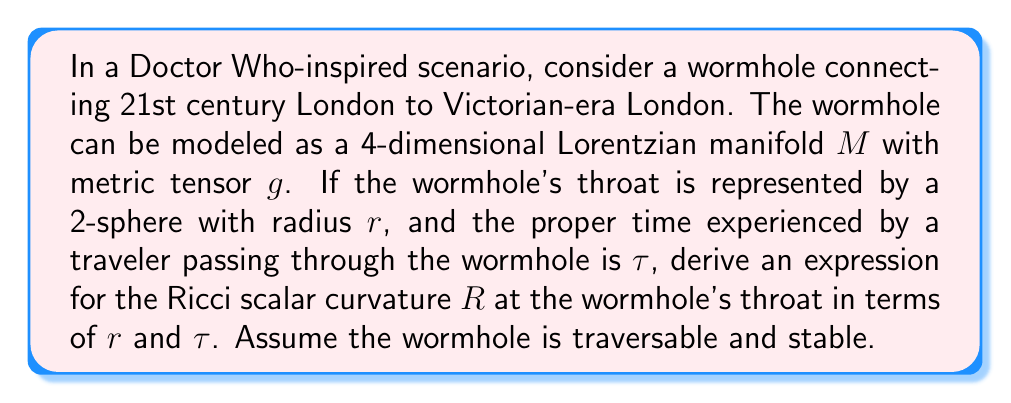Teach me how to tackle this problem. To solve this problem, we'll follow these steps:

1) First, recall that for a 4-dimensional Lorentzian manifold, the Ricci scalar curvature $R$ is related to the Einstein tensor $G_{\mu\nu}$ by the trace:

   $$R = -G^{\mu}_{\mu}$$

2) For a traversable wormhole, we can use the Morris-Thorne metric:

   $$ds^2 = -e^{2\Phi(r)}dt^2 + \frac{dr^2}{1-b(r)/r} + r^2(d\theta^2 + \sin^2\theta d\phi^2)$$

   where $\Phi(r)$ is the redshift function and $b(r)$ is the shape function.

3) At the wormhole's throat, $r = b(r) = r_0$, where $r_0$ is the throat radius. For simplicity, let's assume $\Phi(r) = 0$ (no redshift).

4) The proper time $\tau$ for a traveler passing through the wormhole is related to the coordinate time $t$ by:

   $$d\tau = e^{\Phi(r)}dt = dt$$ (since $\Phi(r) = 0$)

5) For a stable wormhole, the Einstein field equations must be satisfied. At the throat, this leads to:

   $$G^t_t = -\frac{b'}{r_0^2}$$
   $$G^r_r = \frac{b}{r_0^3}$$
   $$G^\theta_\theta = G^\phi_\phi = -\frac{b}{2r_0^3}$$

6) The trace of the Einstein tensor is:

   $$G^{\mu}_{\mu} = G^t_t + G^r_r + G^\theta_\theta + G^\phi_\phi = -\frac{b'}{r_0^2} + \frac{b}{r_0^3} - \frac{b}{r_0^3} = -\frac{b'}{r_0^2}$$

7) At the throat, $b' < 1$ for the wormhole to be traversable. Let's assume $b' = 1 - \epsilon$, where $\epsilon$ is small and positive.

8) Substituting into the Ricci scalar equation:

   $$R = -G^{\mu}_{\mu} = \frac{b'}{r_0^2} = \frac{1-\epsilon}{r_0^2}$$

9) The proper time $\tau$ for traversing the wormhole is related to the throat radius $r_0$ by:

   $$\tau \approx \pi r_0$$

   This is because the shortest path through the wormhole is approximately half the circumference of the throat.

10) Solving for $r_0$:

    $$r_0 \approx \frac{\tau}{\pi}$$

11) Substituting this into our expression for $R$:

    $$R \approx \frac{1-\epsilon}{(\tau/\pi)^2} = \frac{\pi^2(1-\epsilon)}{\tau^2}$$
Answer: The Ricci scalar curvature $R$ at the wormhole's throat is approximately:

$$R \approx \frac{\pi^2(1-\epsilon)}{\tau^2}$$

where $\tau$ is the proper time for traversing the wormhole and $\epsilon$ is a small positive number (close to zero) ensuring the wormhole is traversable. 